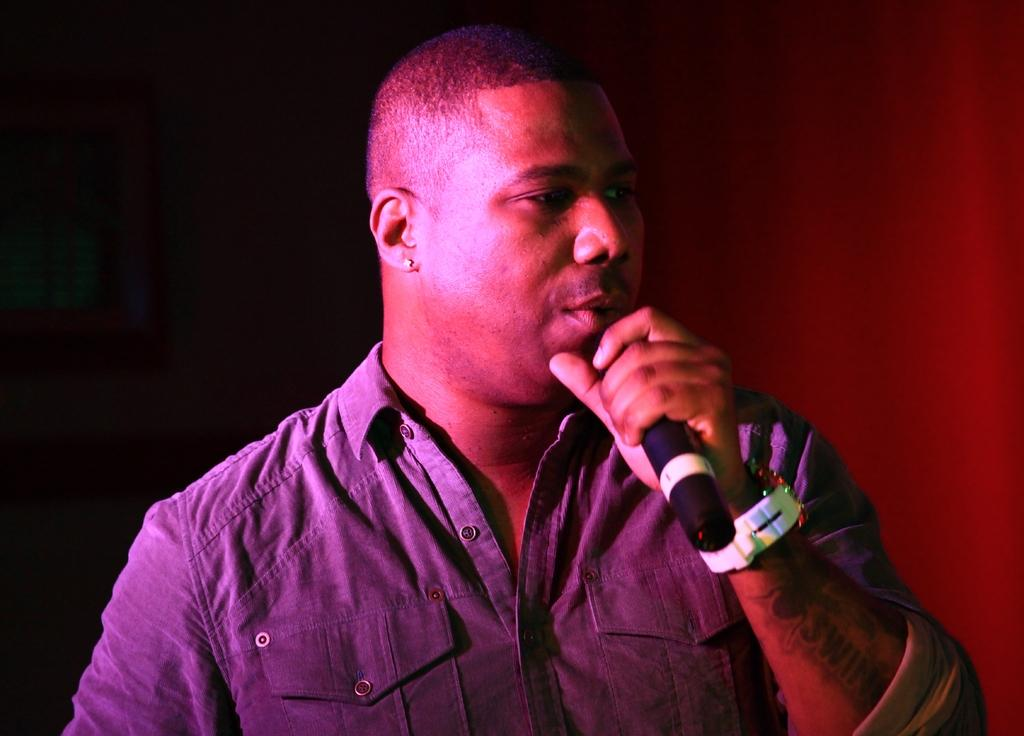Who or what is the main subject in the image? There is a person in the image. Can you describe the position of the person in the image? The person is standing in the middle of the image. What is the person holding in the image? The person is holding a microphone (Mic). What type of agreement is being discussed by the police in the image? There are no police or discussions about agreements present in the image; it features a person holding a microphone. 